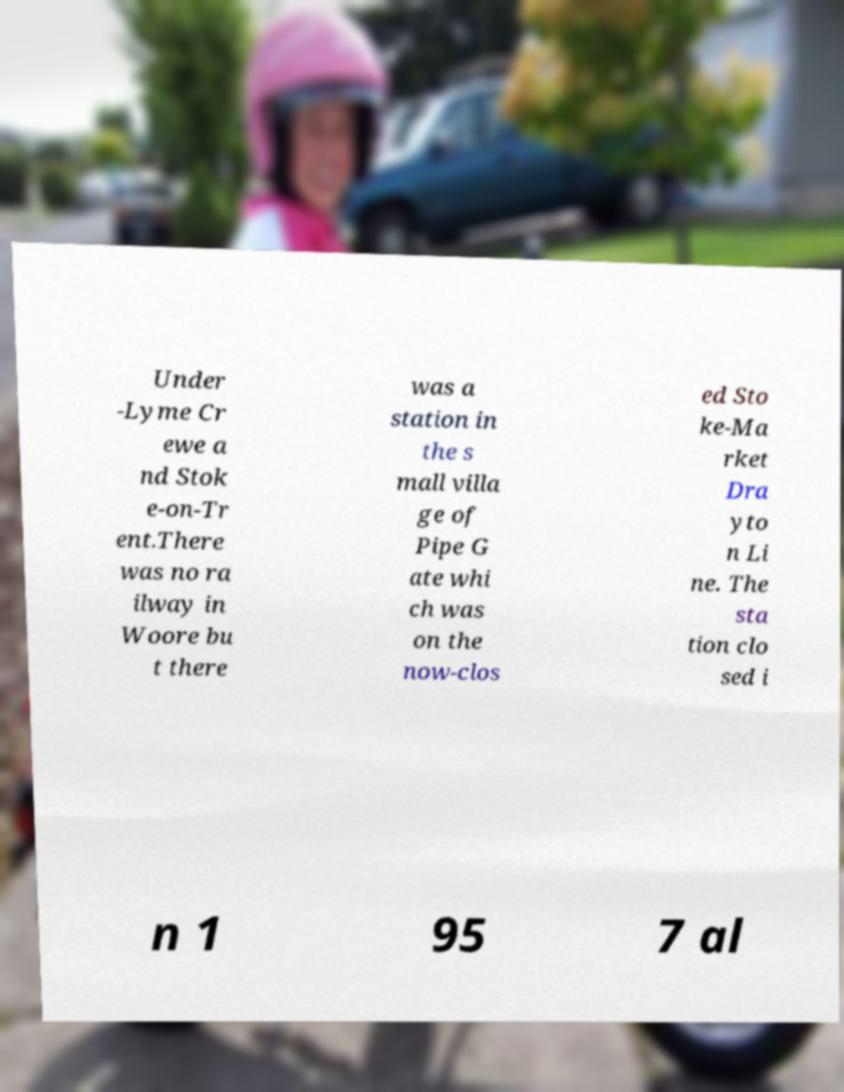Can you read and provide the text displayed in the image?This photo seems to have some interesting text. Can you extract and type it out for me? Under -Lyme Cr ewe a nd Stok e-on-Tr ent.There was no ra ilway in Woore bu t there was a station in the s mall villa ge of Pipe G ate whi ch was on the now-clos ed Sto ke-Ma rket Dra yto n Li ne. The sta tion clo sed i n 1 95 7 al 